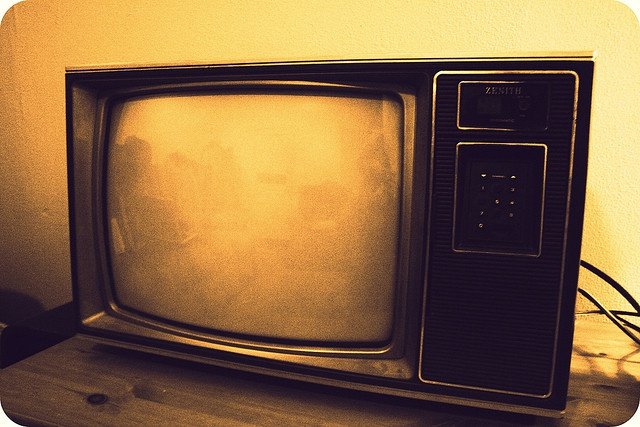Describe the objects in this image and their specific colors. I can see a tv in ivory, black, orange, gray, and gold tones in this image. 